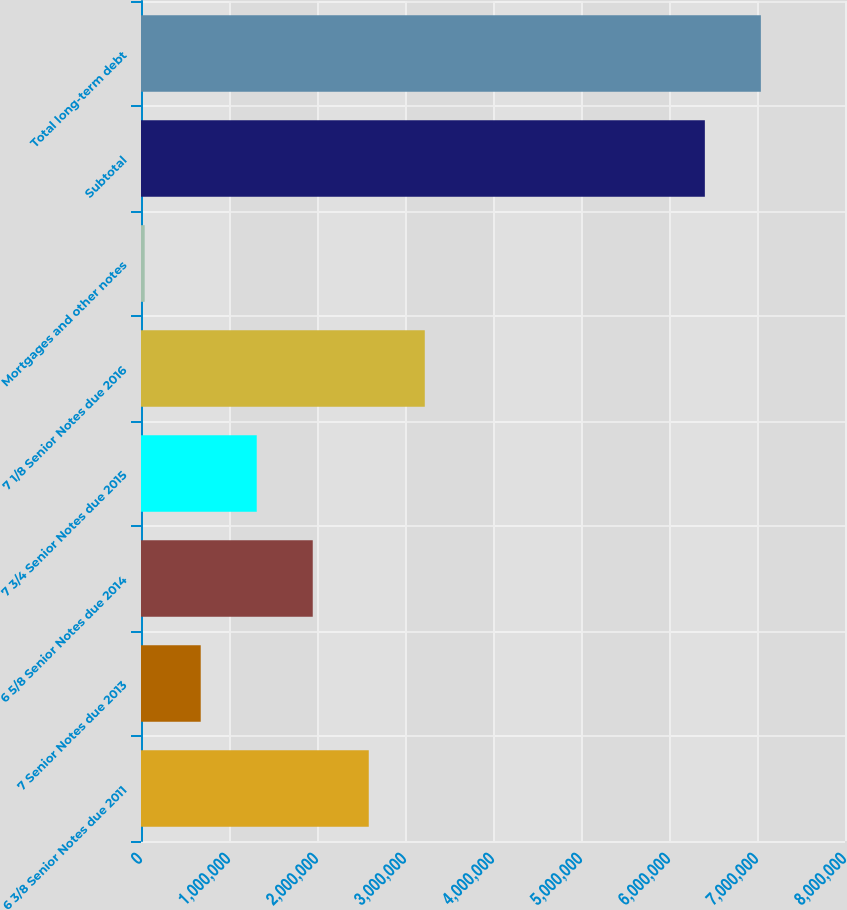<chart> <loc_0><loc_0><loc_500><loc_500><bar_chart><fcel>6 3/8 Senior Notes due 2011<fcel>7 Senior Notes due 2013<fcel>6 5/8 Senior Notes due 2014<fcel>7 3/4 Senior Notes due 2015<fcel>7 1/8 Senior Notes due 2016<fcel>Mortgages and other notes<fcel>Subtotal<fcel>Total long-term debt<nl><fcel>2.58826e+06<fcel>678644<fcel>1.95172e+06<fcel>1.31518e+06<fcel>3.22479e+06<fcel>42107<fcel>6.40748e+06<fcel>7.04402e+06<nl></chart> 